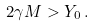Convert formula to latex. <formula><loc_0><loc_0><loc_500><loc_500>2 \gamma M > Y _ { 0 } \, .</formula> 